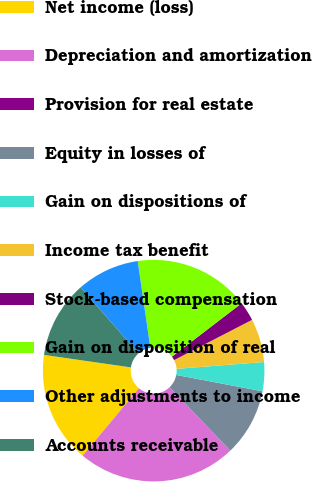Convert chart. <chart><loc_0><loc_0><loc_500><loc_500><pie_chart><fcel>Net income (loss)<fcel>Depreciation and amortization<fcel>Provision for real estate<fcel>Equity in losses of<fcel>Gain on dispositions of<fcel>Income tax benefit<fcel>Stock-based compensation<fcel>Gain on disposition of real<fcel>Other adjustments to income<fcel>Accounts receivable<nl><fcel>16.2%<fcel>23.24%<fcel>0.0%<fcel>9.86%<fcel>4.23%<fcel>6.34%<fcel>2.82%<fcel>16.9%<fcel>9.16%<fcel>11.27%<nl></chart> 